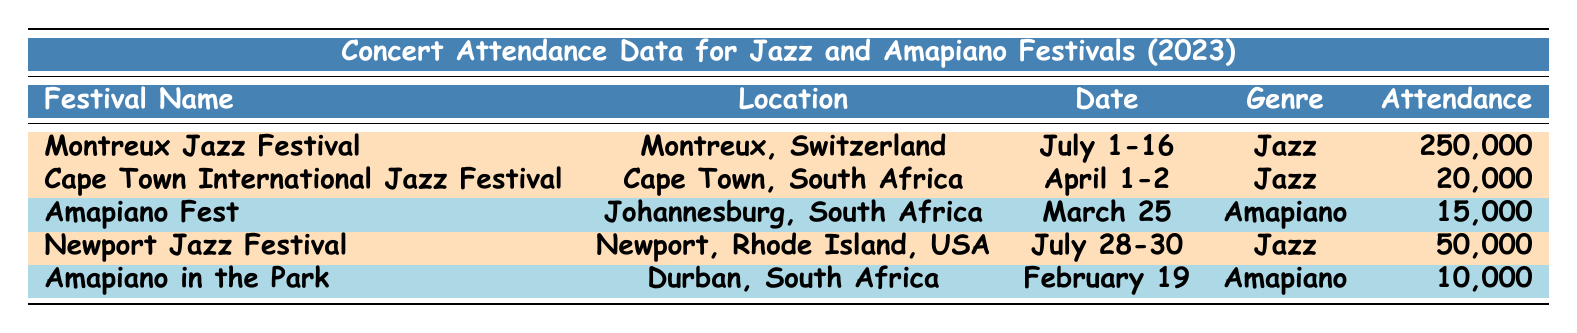What is the total attendance at all jazz festivals listed? The attendance numbers for the jazz festivals are 250,000 (Montreux), 20,000 (Cape Town), and 50,000 (Newport). Summing these values gives 250,000 + 20,000 + 50,000 = 320,000.
Answer: 320,000 Which Amapiano festival had the highest attendance? There are two Amapiano festivals listed: Amapiano Fest with 15,000 attendees and Amapiano in the Park with 10,000 attendees. Amapiano Fest has the higher attendance.
Answer: Amapiano Fest Is the Cape Town International Jazz Festival held before the Montreux Jazz Festival? The Cape Town International Jazz Festival occurs on April 1-2, while the Montreux Jazz Festival runs from July 1-16. Since April comes before July, Cape Town is held earlier.
Answer: Yes What percentage of total attendance at jazz festivals does Montreux Jazz Festival account for? The total attendance at the jazz festivals is 320,000. The Montreux attendance is 250,000. To find the percentage, (250,000 / 320,000) * 100 = 78.125%.
Answer: 78.125% How many more people attended the Montreux Jazz Festival compared to the Newport Jazz Festival? Montreux Jazz Festival attendance is 250,000 and Newport Jazz Festival attendance is 50,000. The difference is 250,000 - 50,000 = 200,000.
Answer: 200,000 Which genre had the lowest total attendance across the festivals? Jazz festivals had a total of 320,000 attendees, while Amapiano festivals had a total of 25,000 (15,000 + 10,000). Comparing the two, Amapiano has the lower total attendance.
Answer: Amapiano If you combine the attendance from both Amapiano festivals, how does that compare to the Newport Jazz Festival attendance? The combined attendance for Amapiano festivals is 15,000 + 10,000 = 25,000. The Newport Jazz Festival had 50,000 attendees. Comparing the two, 25,000 is less than 50,000.
Answer: Less What is the average attendance for the Amapiano festivals? The Amapiano festivals had attendances of 15,000 and 10,000. To calculate the average, sum these (15,000 + 10,000 = 25,000) and divide by 2, giving 25,000 / 2 = 12,500.
Answer: 12,500 